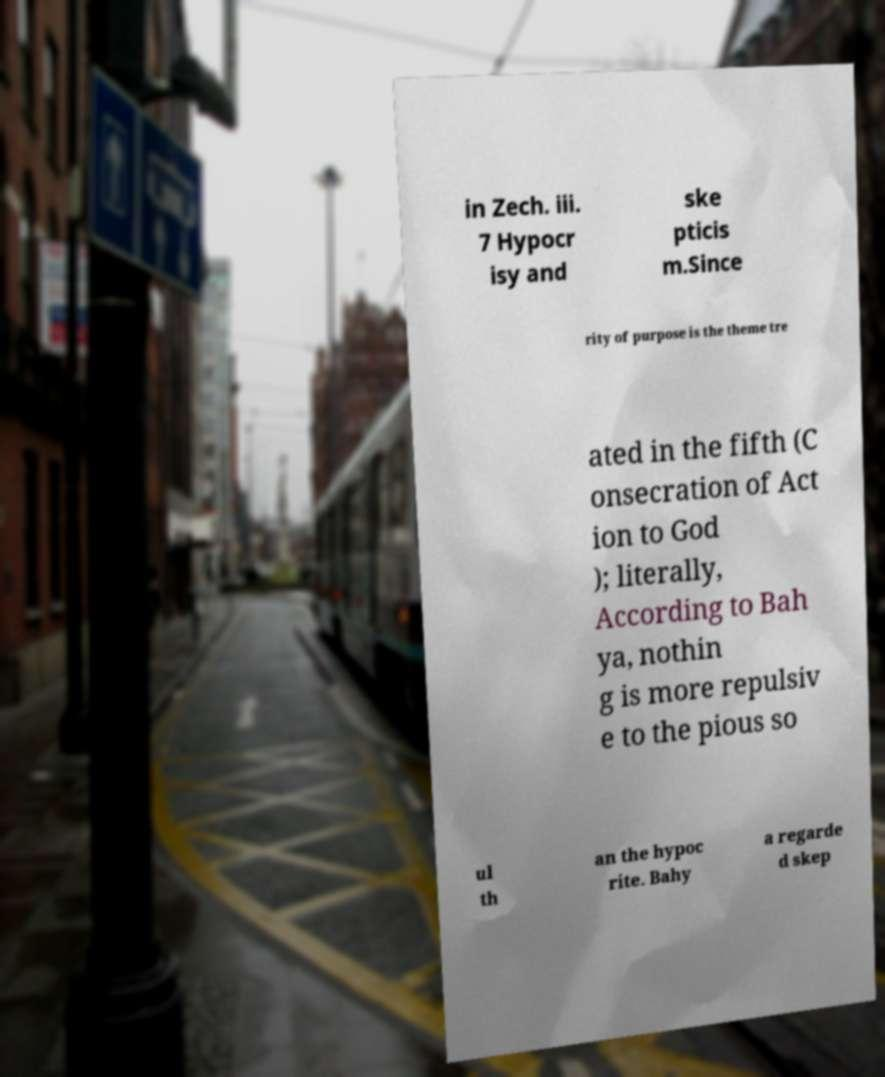There's text embedded in this image that I need extracted. Can you transcribe it verbatim? in Zech. iii. 7 Hypocr isy and ske pticis m.Since rity of purpose is the theme tre ated in the fifth (C onsecration of Act ion to God ); literally, According to Bah ya, nothin g is more repulsiv e to the pious so ul th an the hypoc rite. Bahy a regarde d skep 